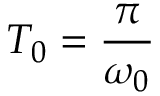<formula> <loc_0><loc_0><loc_500><loc_500>T _ { 0 } = \frac { \pi } { \omega _ { 0 } }</formula> 